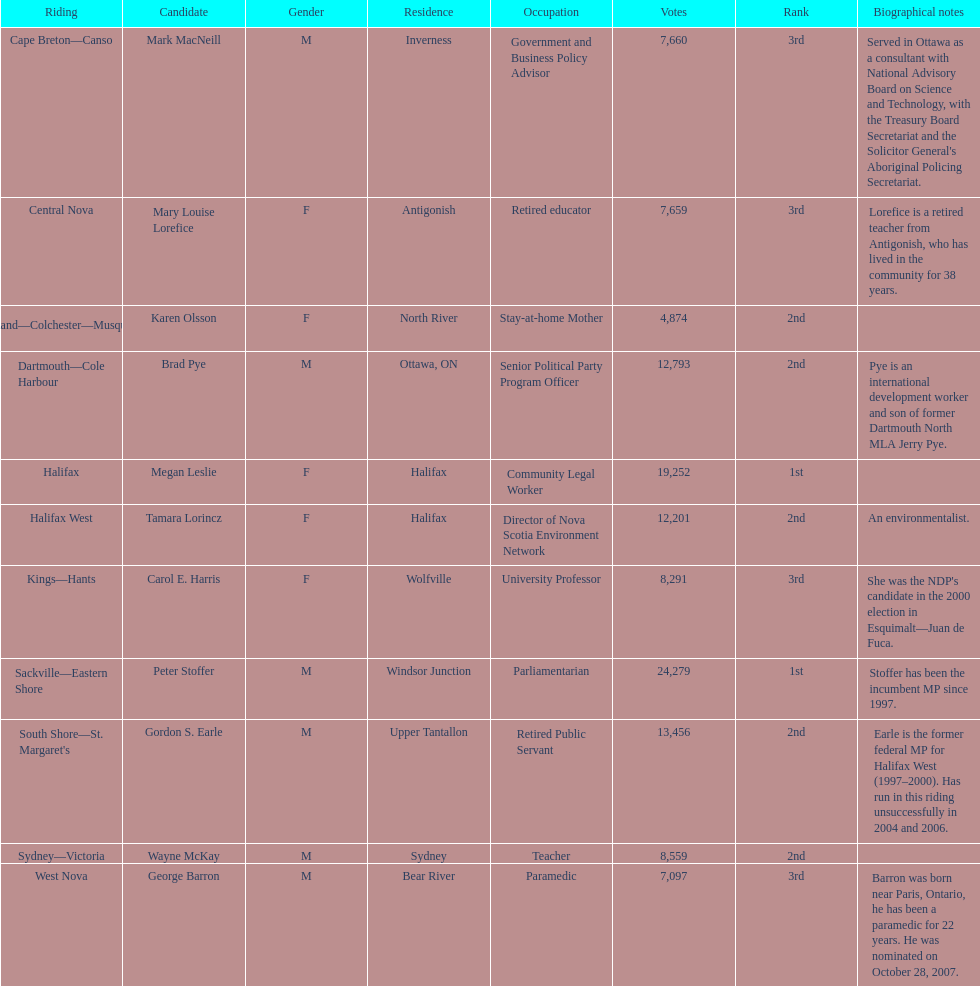Which candidates have the four lowest amount of votes Mark MacNeill, Mary Louise Lorefice, Karen Olsson, George Barron. Out of the following, who has the third most? Mark MacNeill. 